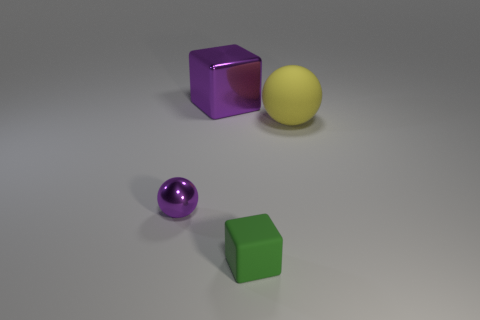Is the size of the green block the same as the metal ball?
Give a very brief answer. Yes. Are there an equal number of big metal objects to the right of the big yellow rubber thing and spheres?
Give a very brief answer. No. There is a big thing that is in front of the purple shiny cube; are there any things that are behind it?
Provide a succinct answer. Yes. What size is the shiny thing behind the purple sphere that is to the left of the large thing right of the purple metal cube?
Give a very brief answer. Large. What is the material of the small thing that is right of the ball left of the big cube?
Your answer should be compact. Rubber. Is there a big purple object that has the same shape as the small green matte object?
Your answer should be very brief. Yes. What is the shape of the big purple object?
Ensure brevity in your answer.  Cube. The cube that is in front of the sphere on the right side of the matte object on the left side of the yellow rubber object is made of what material?
Offer a terse response. Rubber. Are there more large blocks in front of the matte sphere than matte balls?
Your answer should be very brief. No. What is the material of the green object that is the same size as the purple ball?
Your answer should be very brief. Rubber. 